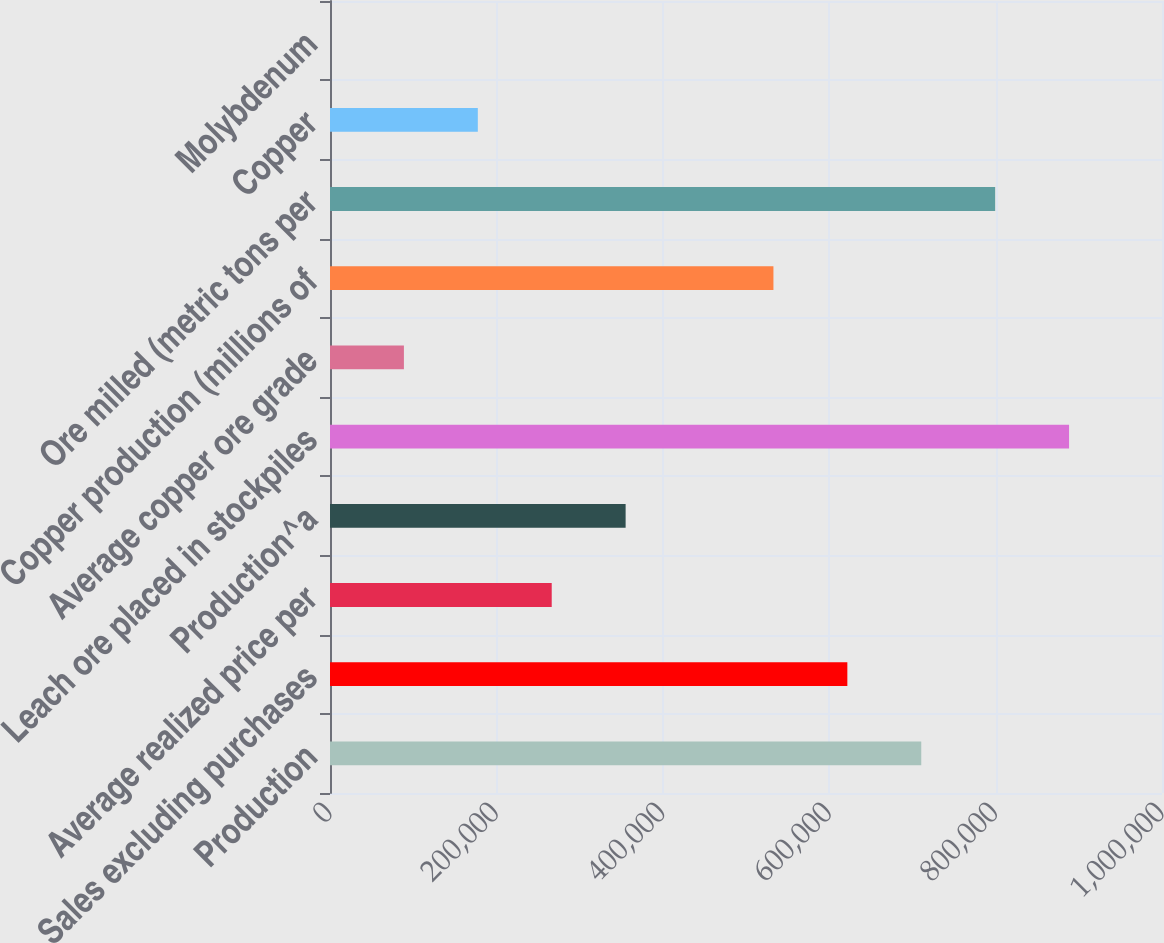Convert chart. <chart><loc_0><loc_0><loc_500><loc_500><bar_chart><fcel>Production<fcel>Sales excluding purchases<fcel>Average realized price per<fcel>Production^a<fcel>Leach ore placed in stockpiles<fcel>Average copper ore grade<fcel>Copper production (millions of<fcel>Ore milled (metric tons per<fcel>Copper<fcel>Molybdenum<nl><fcel>710640<fcel>621810<fcel>266490<fcel>355320<fcel>888300<fcel>88830<fcel>532980<fcel>799470<fcel>177660<fcel>0.03<nl></chart> 